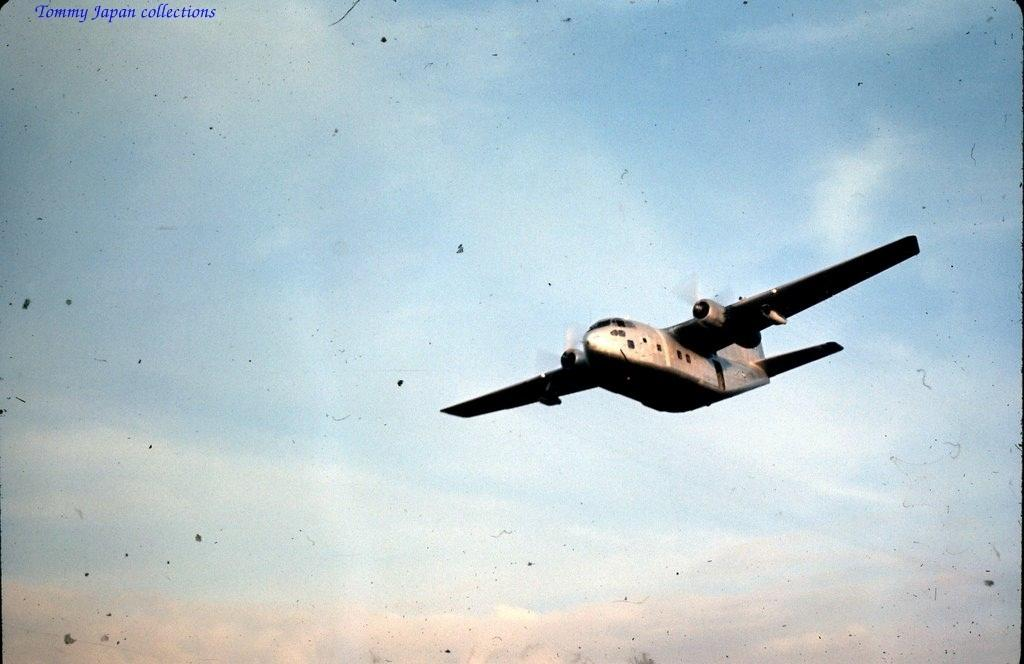What is the main subject of the image? The main subject of the image is a flying jet. Where is the jet located in the image? The jet is in the sky. How would you describe the sky in the image? The sky is cloudy. Is there any additional information or markings on the image? Yes, there is a watermark at the left top of the image. What type of brick is being used to build the tramp in the image? There is no brick or tramp present in the image; it features a flying jet in a cloudy sky. Who is the manager of the jet in the image? The image does not depict a manager or any personnel related to the jet's operation. 